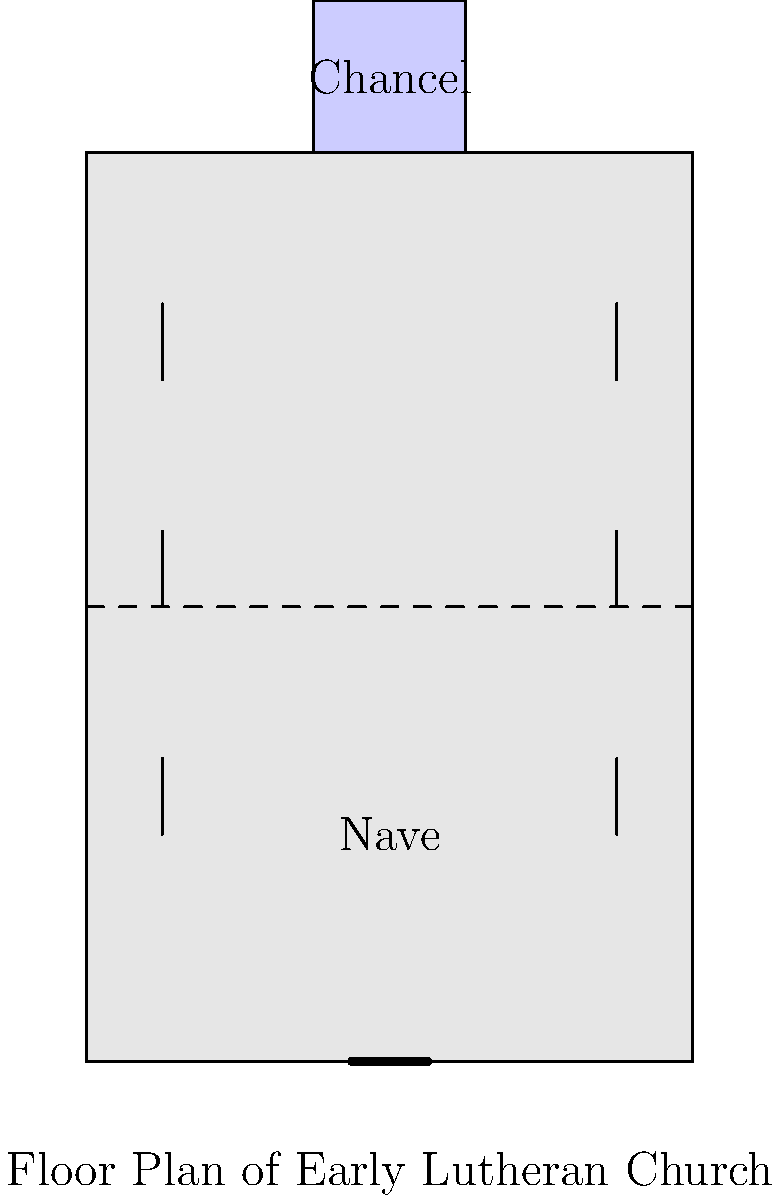In the floor plan of an early Lutheran church shown above, what architectural feature is prominently displayed at the north end of the church, and how does this reflect Lutheran theology? To answer this question, let's analyze the floor plan step-by-step:

1. Orientation: In traditional church architecture, the altar is typically placed at the east end. However, in this diagram, we'll consider the top of the image as north for consistency with the question.

2. North end feature: At the north end of the church, we can see a rectangular area that extends beyond the main body of the church. This area is labeled as the "Chancel."

3. Chancel significance: The chancel is the space around the altar in a church building. It's usually where the clergy and choir are seated and where the Eucharist is celebrated.

4. Lutheran theology reflection: The prominence of the chancel in Lutheran churches reflects several key aspects of Lutheran theology:

   a) Emphasis on the Word: The chancel often houses the pulpit, emphasizing the importance of preaching and the Word of God in Lutheran worship.
   
   b) Centrality of the Sacraments: The altar in the chancel is the focus for the celebration of the Eucharist, which Luther considered a crucial sacrament.
   
   c) Priesthood of all believers: Unlike in Catholic churches, there's typically no rood screen separating the chancel from the nave, reflecting Luther's teaching that all believers have direct access to God.
   
   d) Simplicity: The chancel's design is usually simpler compared to Catholic churches, reflecting Luther's emphasis on removing distractions from worship.

5. Contrast with Catholic churches: In many Catholic churches, the chancel might be less prominent or more separated from the congregation, often with elaborate decorations. The Lutheran design emphasizes a more direct connection between the congregation and the liturgical space.

Therefore, the prominent architectural feature at the north end is the chancel, and its design reflects key aspects of Lutheran theology, particularly the emphasis on the Word and Sacraments, and the concept of the priesthood of all believers.
Answer: The chancel, reflecting Lutheran emphasis on Word and Sacraments and the priesthood of all believers. 